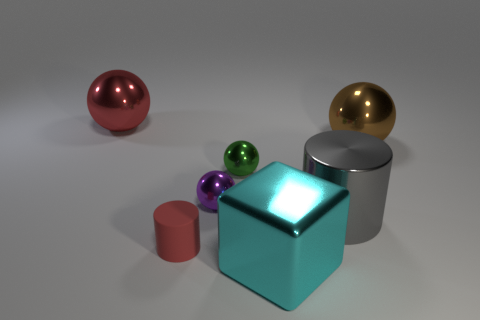There is a tiny matte thing; is it the same color as the ball that is on the left side of the small rubber thing?
Make the answer very short. Yes. Is the number of large gray metallic objects behind the big brown sphere less than the number of tiny yellow things?
Your response must be concise. No. What number of large red spheres are there?
Offer a terse response. 1. The large object to the left of the small thing that is in front of the purple ball is what shape?
Make the answer very short. Sphere. There is a big cube; what number of large gray shiny cylinders are left of it?
Your response must be concise. 0. Do the small red cylinder and the red object on the left side of the rubber thing have the same material?
Your answer should be very brief. No. Are there any spheres of the same size as the brown object?
Make the answer very short. Yes. Are there an equal number of large brown metal spheres that are on the left side of the small matte thing and large yellow rubber objects?
Your response must be concise. Yes. The matte cylinder has what size?
Give a very brief answer. Small. How many big objects are to the left of the big sphere to the right of the green thing?
Your response must be concise. 3. 